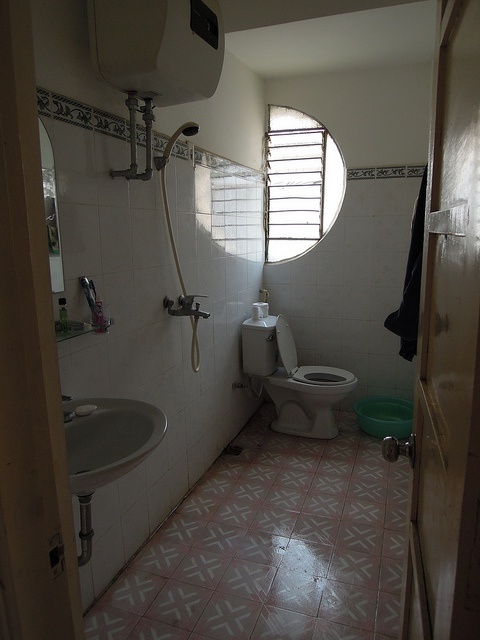Describe the objects in this image and their specific colors. I can see toilet in black and gray tones and sink in black and gray tones in this image. 